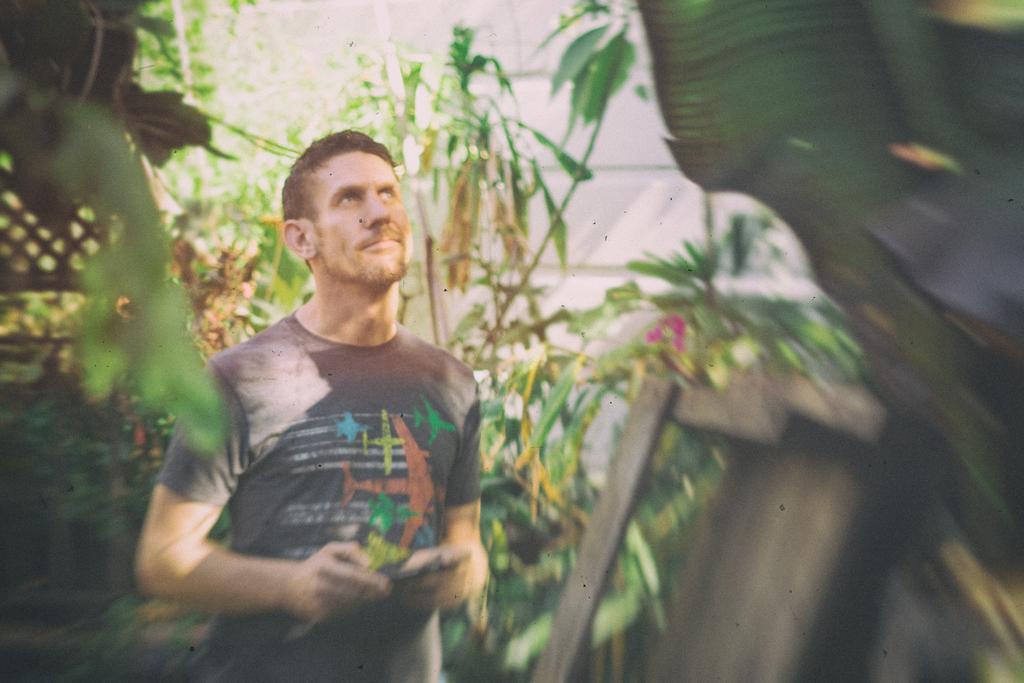Can you describe this image briefly? In this picture there is a man who is wearing t-shirt and holding a mobile phone. He is standing near to the plants. On the left we can see the wooden table near to the wall. On the left we can see the wooden partition. 